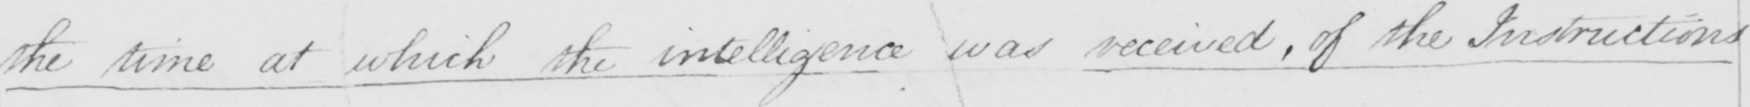Please provide the text content of this handwritten line. the time at which the intelligence was received , of the Instructions 